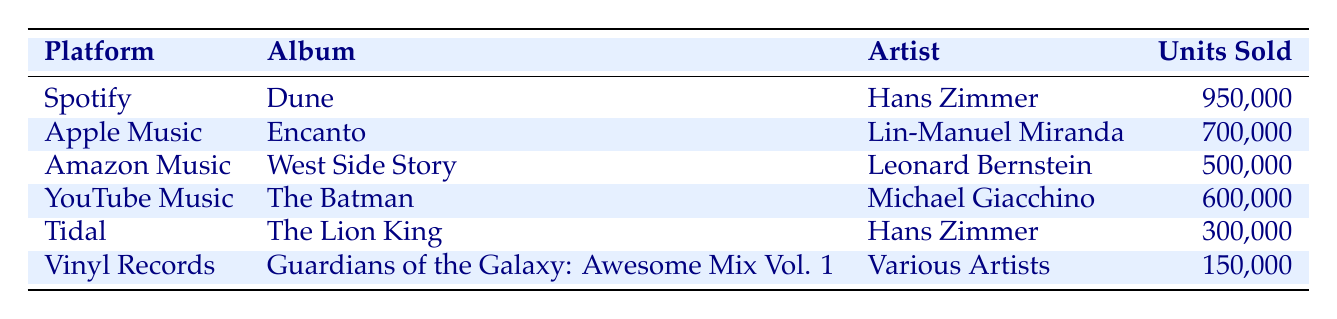What is the highest-selling film soundtrack album on Spotify? The table indicates that "Dune (Original Motion Picture Soundtrack)" by Hans Zimmer has sold 950,000 units on Spotify, making it the highest-selling album on that platform.
Answer: Dune (Original Motion Picture Soundtrack) Which film soundtrack sold the most units across all platforms? By comparing the units sold across all the film soundtracks listed, "Dune (Original Motion Picture Soundtrack)" with 950,000 units sold is the highest, so it sold the most units overall.
Answer: Dune (Original Motion Picture Soundtrack) Is "The Lion King (Original Motion Picture Soundtrack)" by Hans Zimmer available on Apple Music? According to the table, the album "The Lion King (Original Motion Picture Soundtrack)" is listed only under Tidal, not Apple Music, making this statement false.
Answer: No What is the total number of units sold for "The Batman (Original Motion Picture Soundtrack"? The table states that "The Batman (Original Motion Picture Soundtrack)" sold 600,000 units, which is the answer as it directly lists the value in the table.
Answer: 600,000 What is the average number of units sold for these six soundtracks? To find the average, we first sum the units sold: (950,000 + 700,000 + 500,000 + 600,000 + 300,000 + 150,000) = 3,200,000. There are 6 soundtracks, so dividing the total by the number of albums gives 3,200,000 / 6 = 533,333.33.
Answer: 533,333.33 Which platform sold fewer than 400,000 units? By examining the table, Tidal at 300,000 units and Vinyl Records at 150,000 units are the only platforms that sold fewer than 400,000 units. Therefore, two platforms meet this condition.
Answer: Tidal and Vinyl Records How many units is the difference in sales between "Encanto" and "West Side Story"? Units sold for "Encanto" is 700,000 and for "West Side Story" is 500,000. To find the difference: 700,000 - 500,000 = 200,000. The result shows that "Encanto" sold 200,000 more units than "West Side Story."
Answer: 200,000 Is "Guardians of the Galaxy: Awesome Mix Vol. 1" the least-selling film soundtrack on any platform? The table shows that it has sold 150,000 units, which is indeed less than the sales of all other soundtracks listed. Therefore, this statement is true.
Answer: Yes 